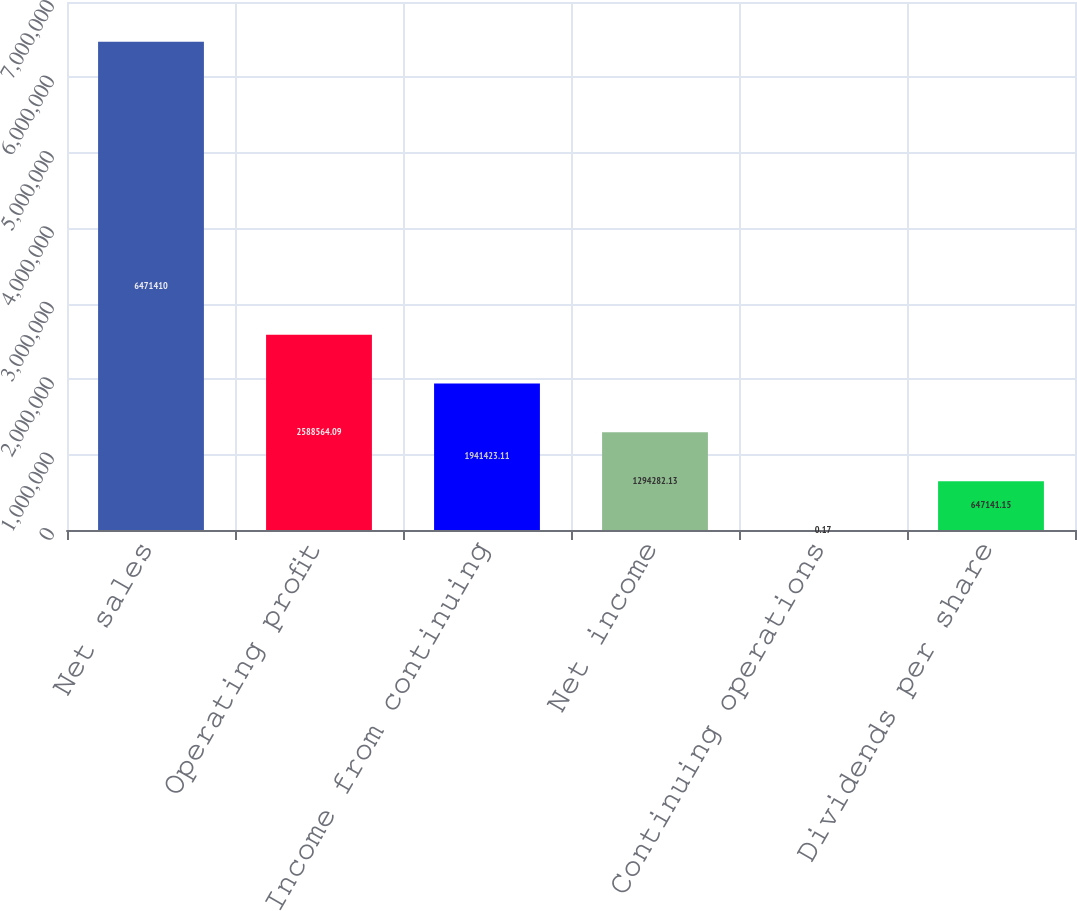Convert chart. <chart><loc_0><loc_0><loc_500><loc_500><bar_chart><fcel>Net sales<fcel>Operating profit<fcel>Income from continuing<fcel>Net income<fcel>Continuing operations<fcel>Dividends per share<nl><fcel>6.47141e+06<fcel>2.58856e+06<fcel>1.94142e+06<fcel>1.29428e+06<fcel>0.17<fcel>647141<nl></chart> 